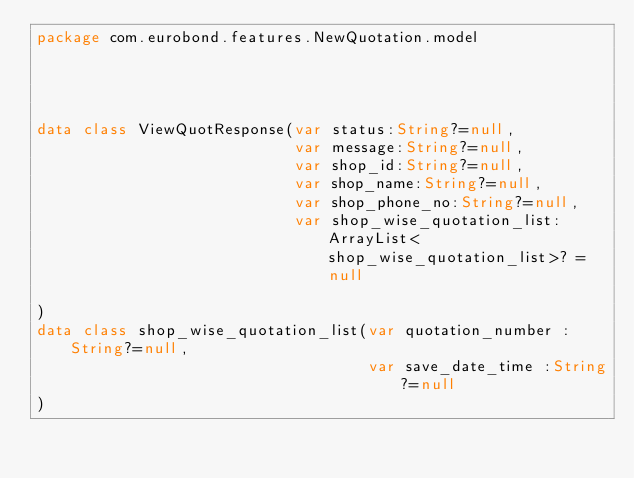<code> <loc_0><loc_0><loc_500><loc_500><_Kotlin_>package com.eurobond.features.NewQuotation.model




data class ViewQuotResponse(var status:String?=null,
                            var message:String?=null,
                            var shop_id:String?=null,
                            var shop_name:String?=null,
                            var shop_phone_no:String?=null,
                            var shop_wise_quotation_list: ArrayList<shop_wise_quotation_list>? = null

)
data class shop_wise_quotation_list(var quotation_number :String?=null,
                                    var save_date_time :String?=null
)</code> 